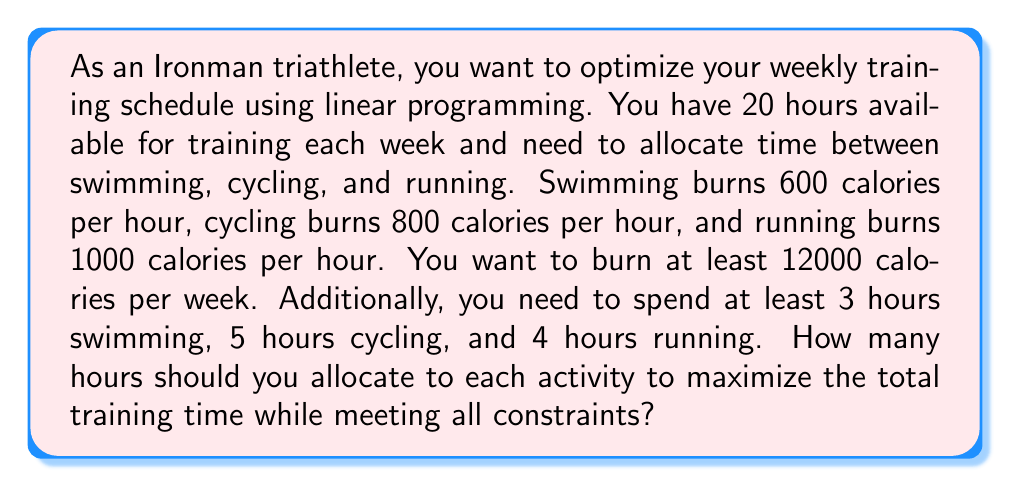What is the answer to this math problem? Let's approach this step-by-step using linear programming:

1) Define variables:
   $x$ = hours spent swimming
   $y$ = hours spent cycling
   $z$ = hours spent running

2) Objective function:
   Maximize $x + y + z$

3) Constraints:
   Time constraint: $x + y + z \leq 20$
   Calorie constraint: $600x + 800y + 1000z \geq 12000$
   Minimum swimming time: $x \geq 3$
   Minimum cycling time: $y \geq 5$
   Minimum running time: $z \geq 4$

4) Set up the linear programming problem:

   Maximize: $x + y + z$
   Subject to:
   $$\begin{align}
   x + y + z &\leq 20 \\
   600x + 800y + 1000z &\geq 12000 \\
   x &\geq 3 \\
   y &\geq 5 \\
   z &\geq 4 \\
   x, y, z &\geq 0
   \end{align}$$

5) Solve using the simplex method or linear programming software.

6) The solution that maximizes total training time while meeting all constraints is:
   $x = 3$ (swimming)
   $y = 5$ (cycling)
   $z = 12$ (running)

7) Verify the solution:
   Total time: $3 + 5 + 12 = 20$ hours (meets time constraint)
   Calories burned: $600(3) + 800(5) + 1000(12) = 14800$ calories (exceeds calorie constraint)
   All minimum time requirements are met.
Answer: Swimming: 3 hours, Cycling: 5 hours, Running: 12 hours 